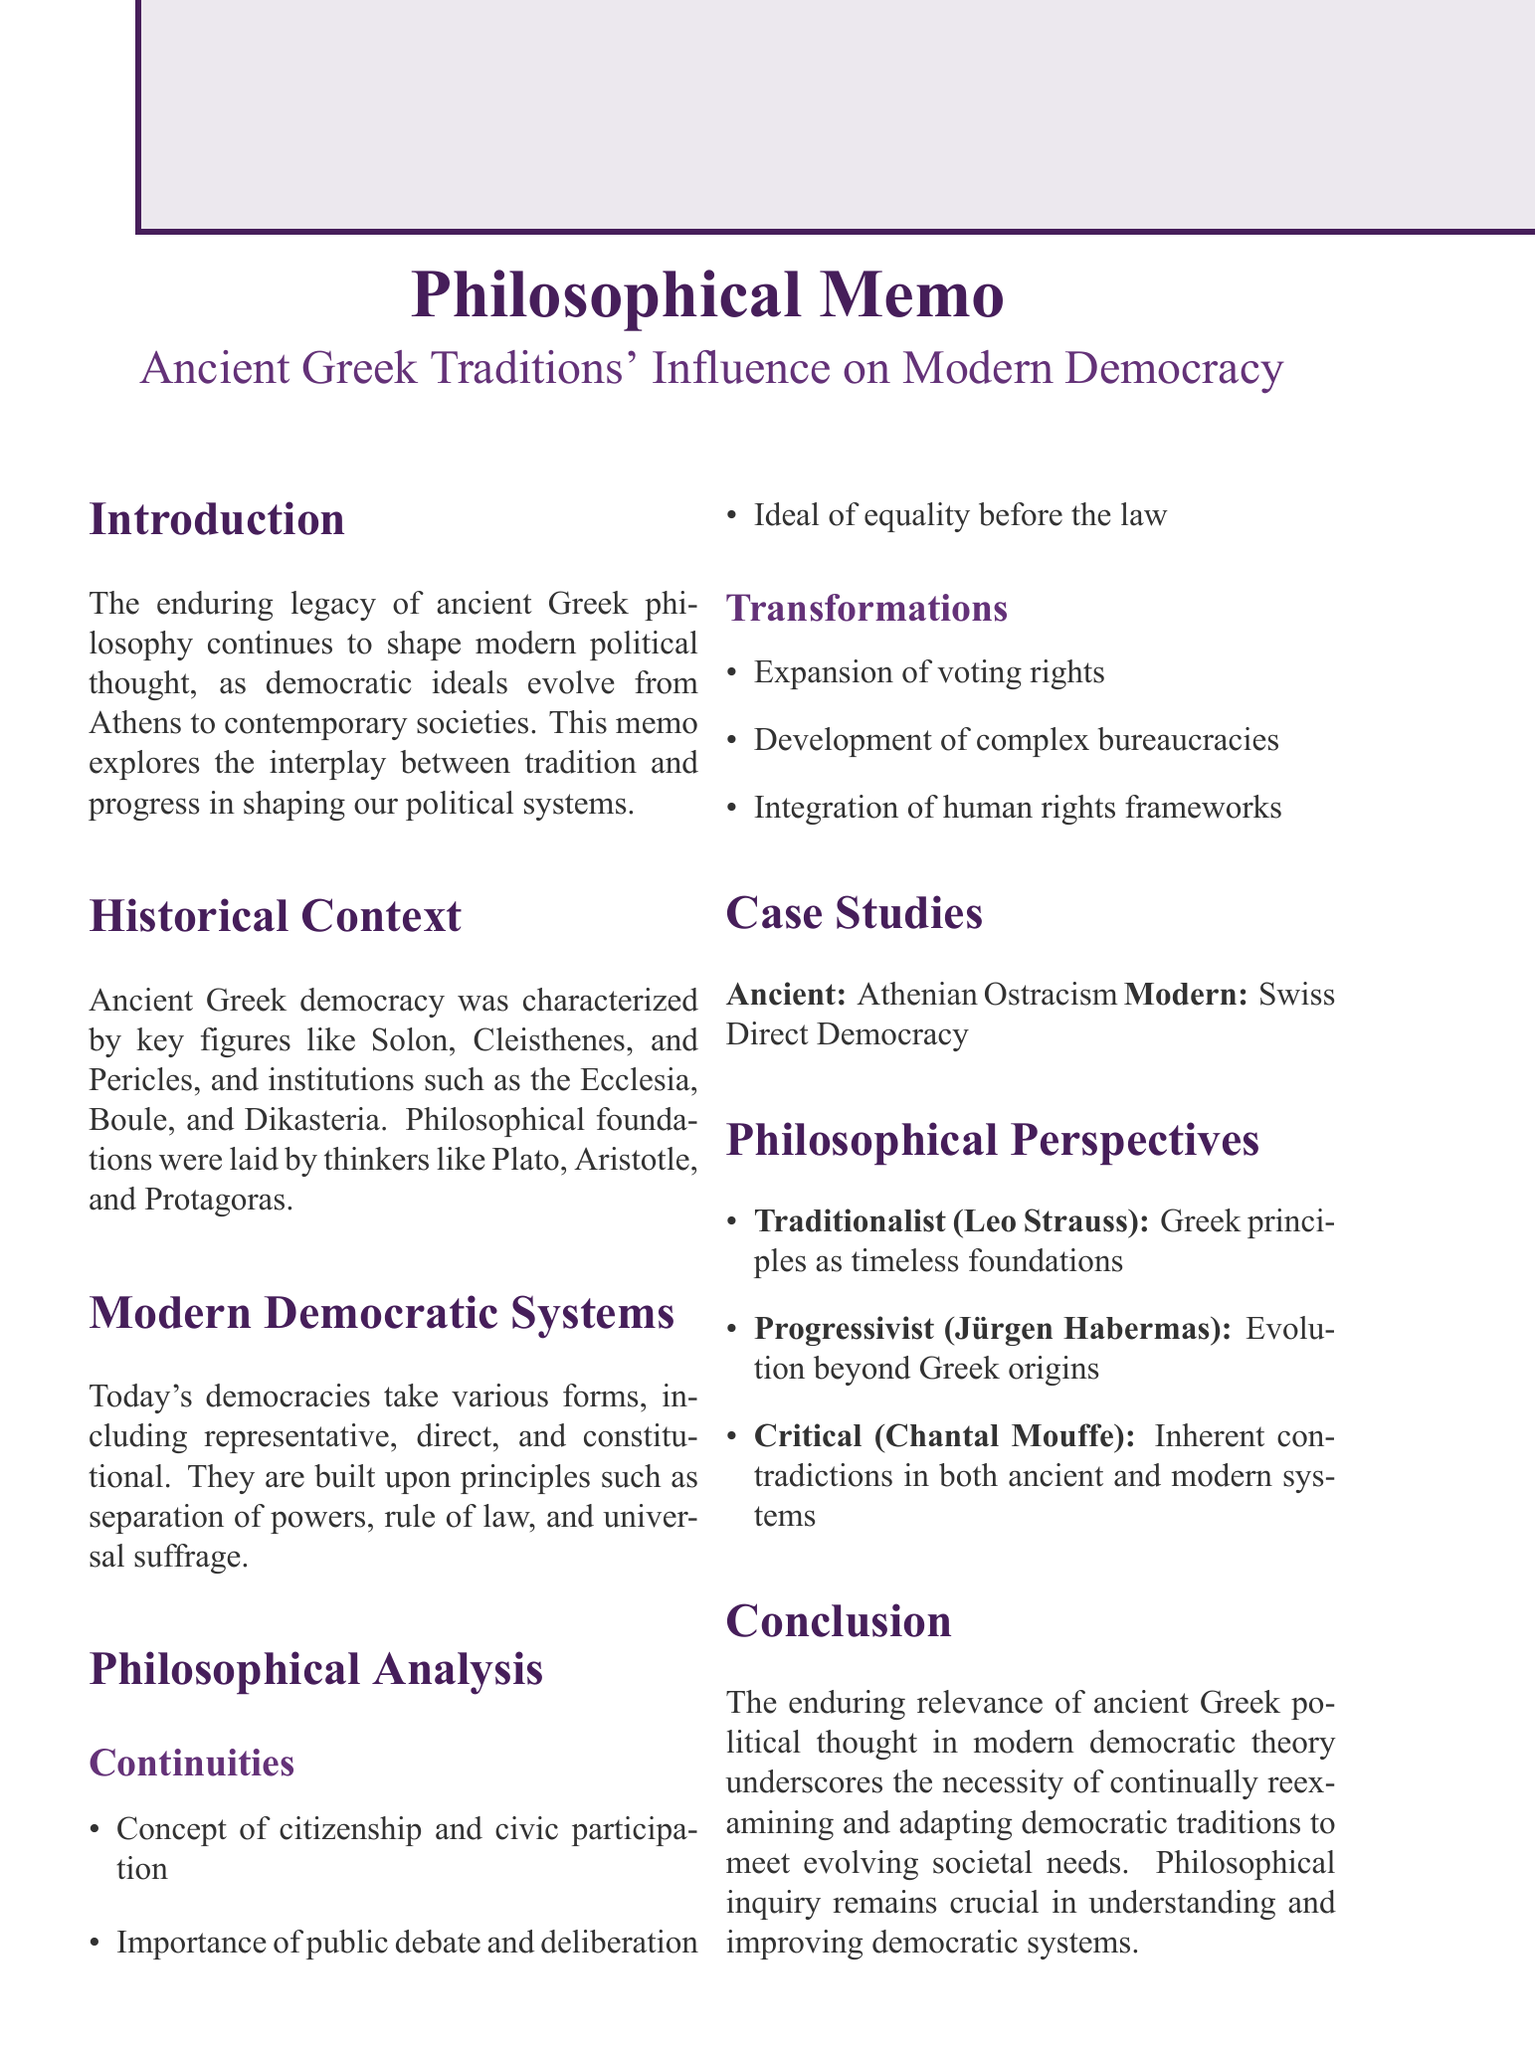What is the title of the memo? The title is explicitly stated at the beginning of the document, summarizing its main topic.
Answer: A Philosophical Analysis of Ancient Greek Traditions' Influence on Modern Democratic Systems Who are three key figures in ancient Greek democracy mentioned in the document? The document lists important historical figures who influenced ancient Greek democracy, including Solon, Cleisthenes, and Pericles.
Answer: Solon, Cleisthenes, Pericles What are the three forms of modern democratic systems discussed? The sections of the document outline different forms of democracy prevalent in modern societies.
Answer: Representative democracy, Direct democracy, Constitutional democracy What is one of the critiques listed in the philosophical analysis? The critique section addresses concerns related to the functioning of modern democratic systems, as described in the document.
Answer: The tension between individual liberty and collective decision-making What argument does Leo Strauss represent in the philosophical perspectives? The document describes differing philosophical perspectives and attributes specific arguments to key figures associated with these views.
Answer: Ancient Greek democratic principles provide a timeless foundation for good governance What modern parallel is drawn with Athenian Ostracism? The case studies section provides examples of historical practices from ancient Greece and their modern equivalents as described in the document.
Answer: Impeachment proceedings in contemporary democracies 